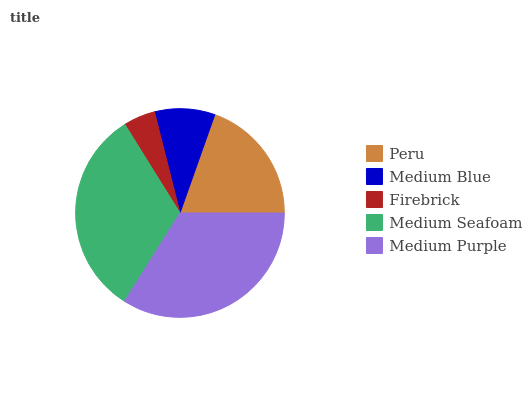Is Firebrick the minimum?
Answer yes or no. Yes. Is Medium Purple the maximum?
Answer yes or no. Yes. Is Medium Blue the minimum?
Answer yes or no. No. Is Medium Blue the maximum?
Answer yes or no. No. Is Peru greater than Medium Blue?
Answer yes or no. Yes. Is Medium Blue less than Peru?
Answer yes or no. Yes. Is Medium Blue greater than Peru?
Answer yes or no. No. Is Peru less than Medium Blue?
Answer yes or no. No. Is Peru the high median?
Answer yes or no. Yes. Is Peru the low median?
Answer yes or no. Yes. Is Medium Seafoam the high median?
Answer yes or no. No. Is Medium Blue the low median?
Answer yes or no. No. 